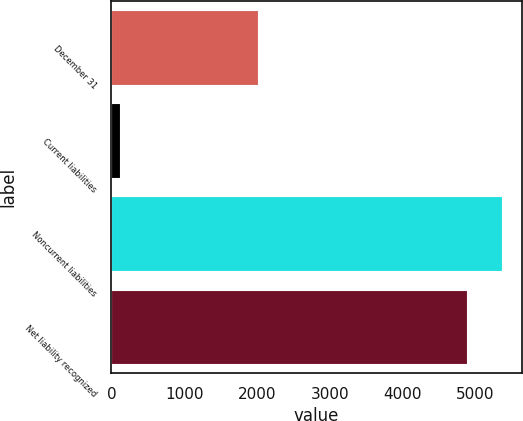Convert chart to OTSL. <chart><loc_0><loc_0><loc_500><loc_500><bar_chart><fcel>December 31<fcel>Current liabilities<fcel>Noncurrent liabilities<fcel>Net liability recognized<nl><fcel>2012<fcel>114<fcel>5367.3<fcel>4887<nl></chart> 